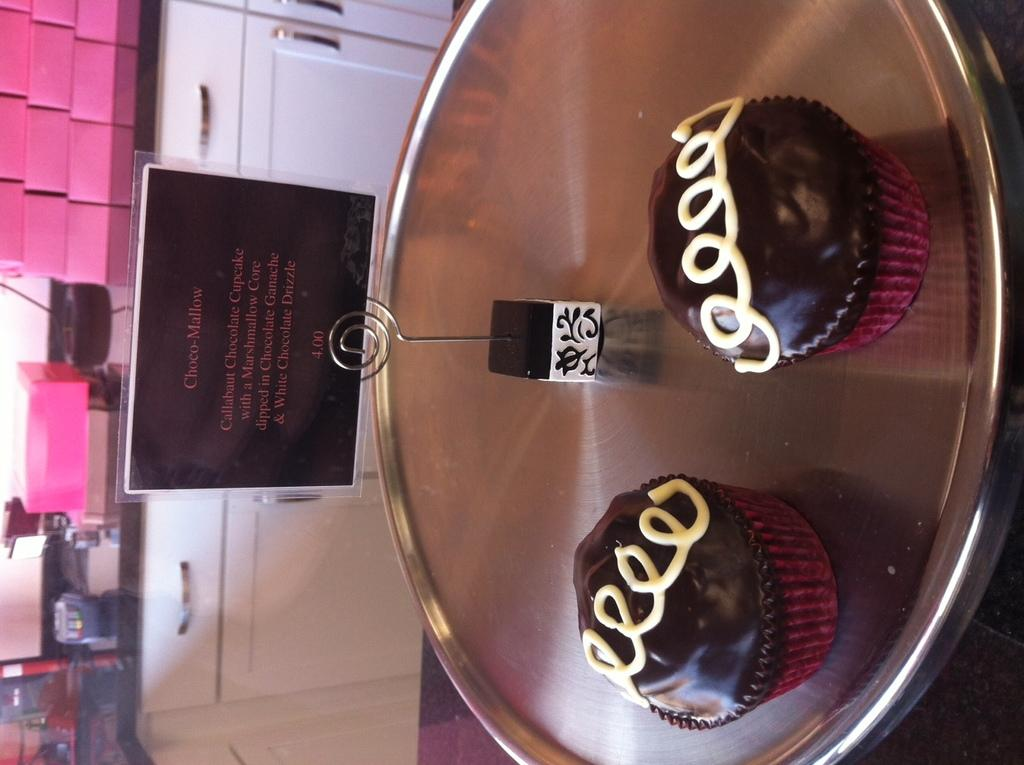<image>
Share a concise interpretation of the image provided. Two Choco-Mallows sit together on a silver tray. 